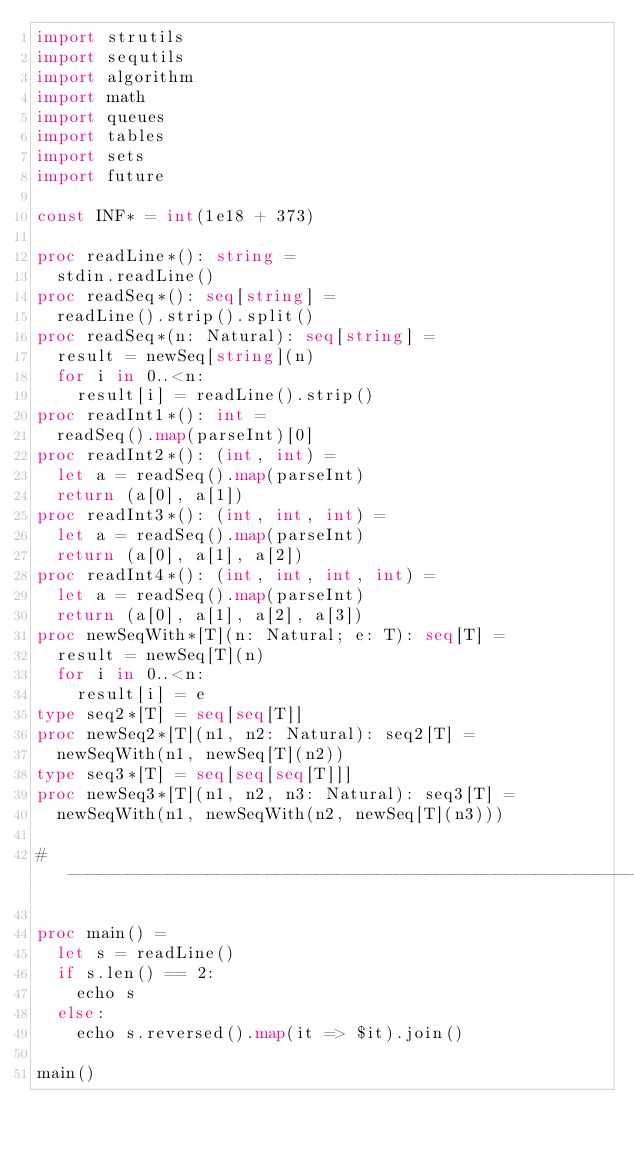Convert code to text. <code><loc_0><loc_0><loc_500><loc_500><_Nim_>import strutils
import sequtils
import algorithm
import math
import queues
import tables
import sets
import future

const INF* = int(1e18 + 373)

proc readLine*(): string =
  stdin.readLine()
proc readSeq*(): seq[string] =
  readLine().strip().split()
proc readSeq*(n: Natural): seq[string] =
  result = newSeq[string](n)
  for i in 0..<n:
    result[i] = readLine().strip()
proc readInt1*(): int =
  readSeq().map(parseInt)[0]
proc readInt2*(): (int, int) =
  let a = readSeq().map(parseInt)
  return (a[0], a[1])
proc readInt3*(): (int, int, int) =
  let a = readSeq().map(parseInt)
  return (a[0], a[1], a[2])
proc readInt4*(): (int, int, int, int) =
  let a = readSeq().map(parseInt)
  return (a[0], a[1], a[2], a[3])
proc newSeqWith*[T](n: Natural; e: T): seq[T] =
  result = newSeq[T](n)
  for i in 0..<n:
    result[i] = e
type seq2*[T] = seq[seq[T]]
proc newSeq2*[T](n1, n2: Natural): seq2[T] =
  newSeqWith(n1, newSeq[T](n2))
type seq3*[T] = seq[seq[seq[T]]]
proc newSeq3*[T](n1, n2, n3: Natural): seq3[T] =
  newSeqWith(n1, newSeqWith(n2, newSeq[T](n3)))

#------------------------------------------------------------------------------#

proc main() =
  let s = readLine()
  if s.len() == 2:
    echo s
  else:
    echo s.reversed().map(it => $it).join()

main()

</code> 